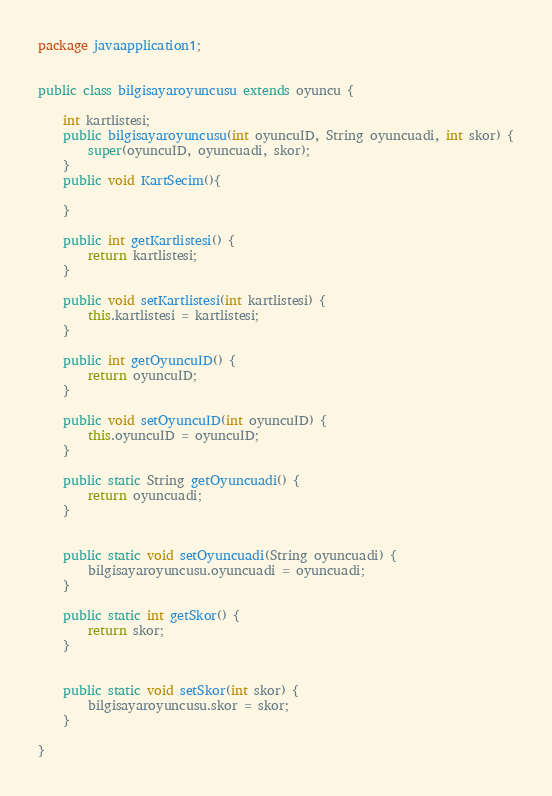<code> <loc_0><loc_0><loc_500><loc_500><_Java_>
package javaapplication1;


public class bilgisayaroyuncusu extends oyuncu {
    
    int kartlistesi;
    public bilgisayaroyuncusu(int oyuncuID, String oyuncuadi, int skor) {
        super(oyuncuID, oyuncuadi, skor);
    }
    public void KartSecim(){
        
    }

    public int getKartlistesi() {
        return kartlistesi;
    }

    public void setKartlistesi(int kartlistesi) {
        this.kartlistesi = kartlistesi;
    }

    public int getOyuncuID() {
        return oyuncuID;
    }

    public void setOyuncuID(int oyuncuID) {
        this.oyuncuID = oyuncuID;
    }

    public static String getOyuncuadi() {
        return oyuncuadi;
    }

    
    public static void setOyuncuadi(String oyuncuadi) {
        bilgisayaroyuncusu.oyuncuadi = oyuncuadi;
    }

    public static int getSkor() {
        return skor;
    }

    
    public static void setSkor(int skor) {
        bilgisayaroyuncusu.skor = skor;
    }
    
}
</code> 